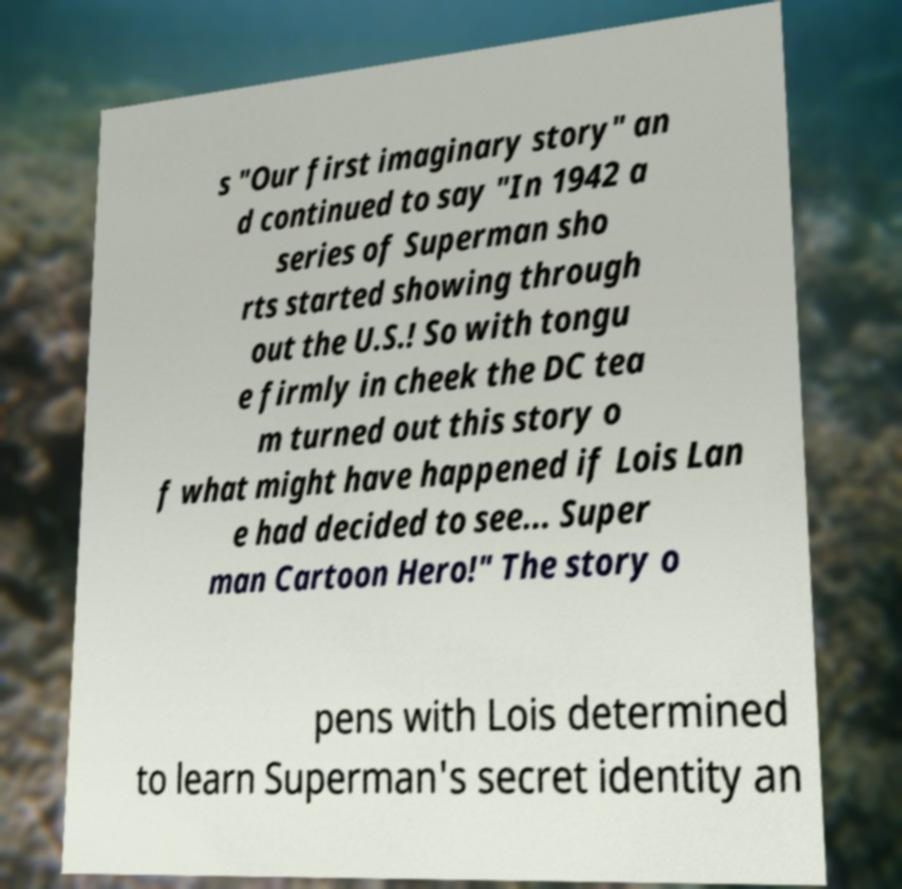There's text embedded in this image that I need extracted. Can you transcribe it verbatim? s "Our first imaginary story" an d continued to say "In 1942 a series of Superman sho rts started showing through out the U.S.! So with tongu e firmly in cheek the DC tea m turned out this story o f what might have happened if Lois Lan e had decided to see... Super man Cartoon Hero!" The story o pens with Lois determined to learn Superman's secret identity an 